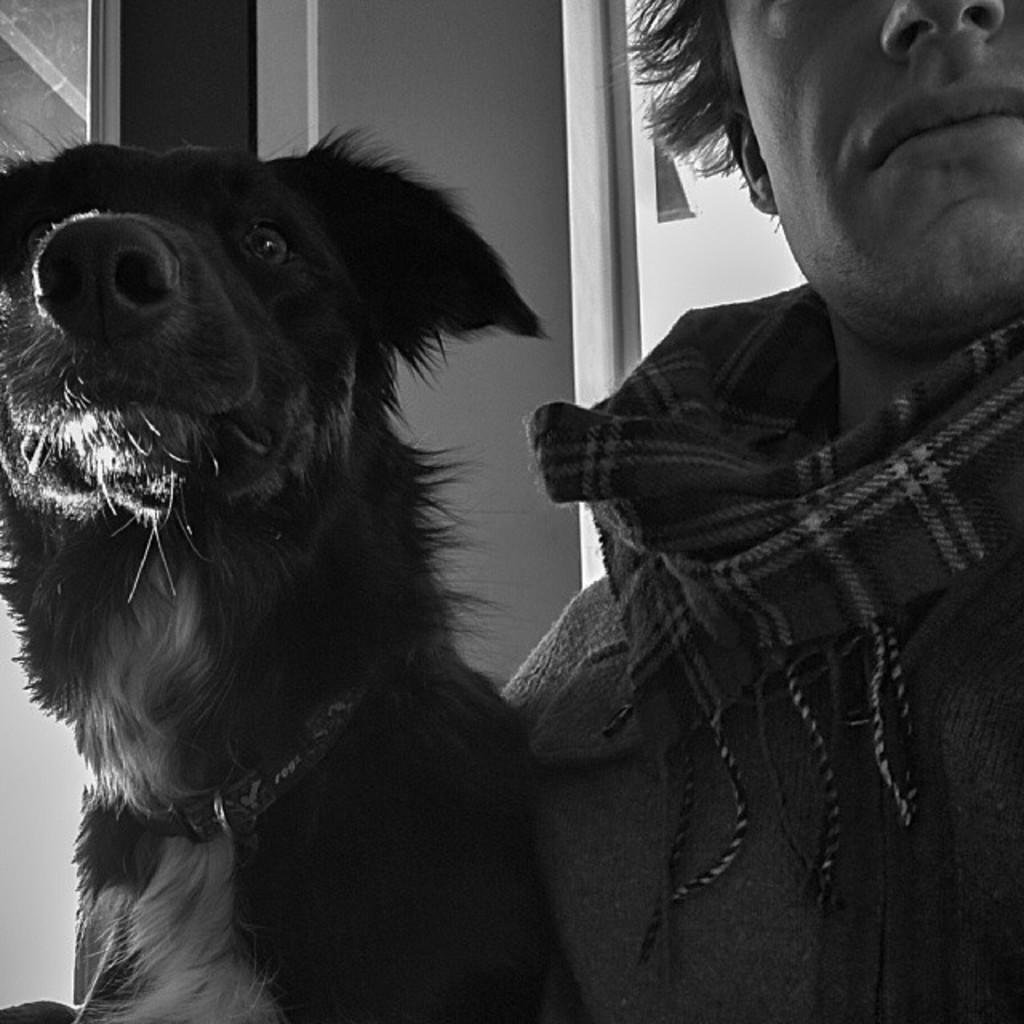Describe this image in one or two sentences. This is the black and white picture. And here we can see a person and dog. 